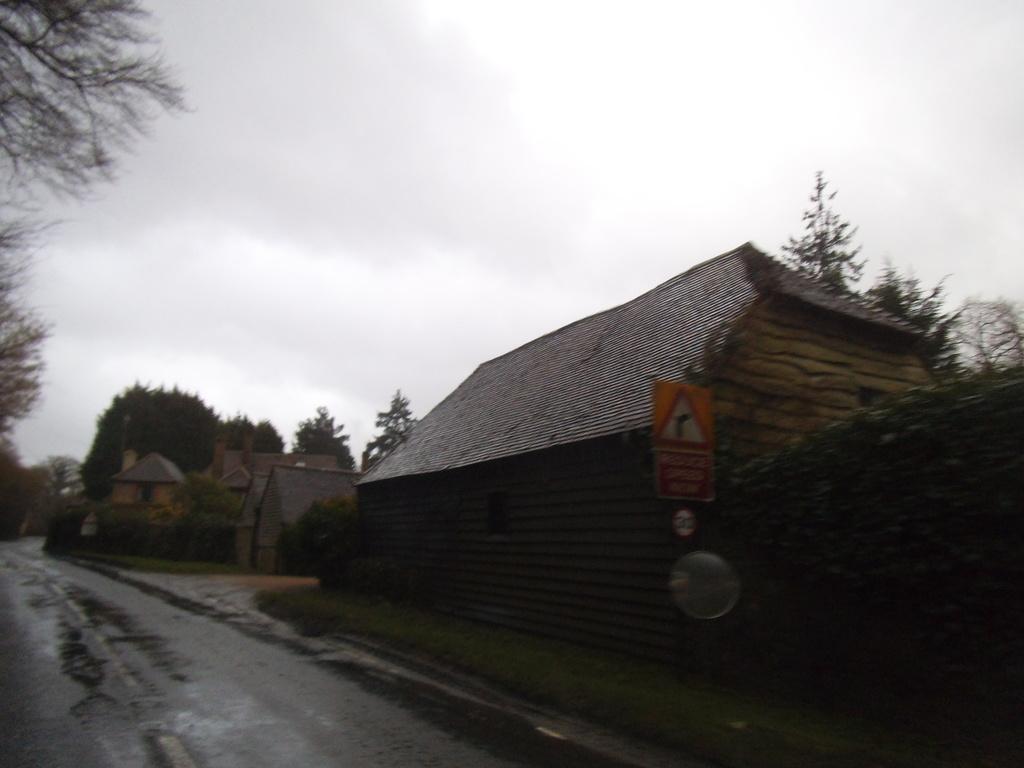Please provide a concise description of this image. On the right side of the image there are houses and trees. On the left side of the image there are trees, in the middle of them there is a road. In the background there is the sky. 